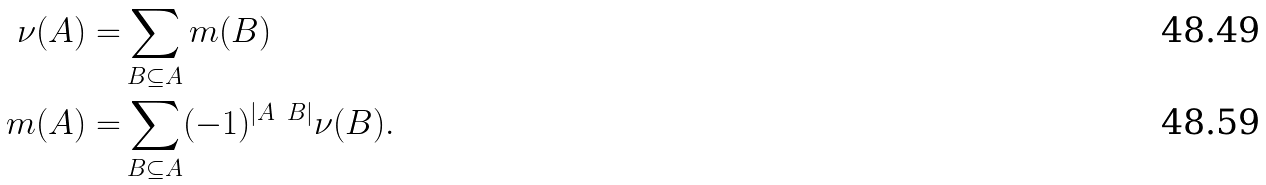Convert formula to latex. <formula><loc_0><loc_0><loc_500><loc_500>\nu ( A ) = & \sum _ { B \subseteq A } m ( B ) \\ m ( A ) = & \sum _ { B \subseteq A } ( - 1 ) ^ { | A \ B | } \nu ( B ) .</formula> 